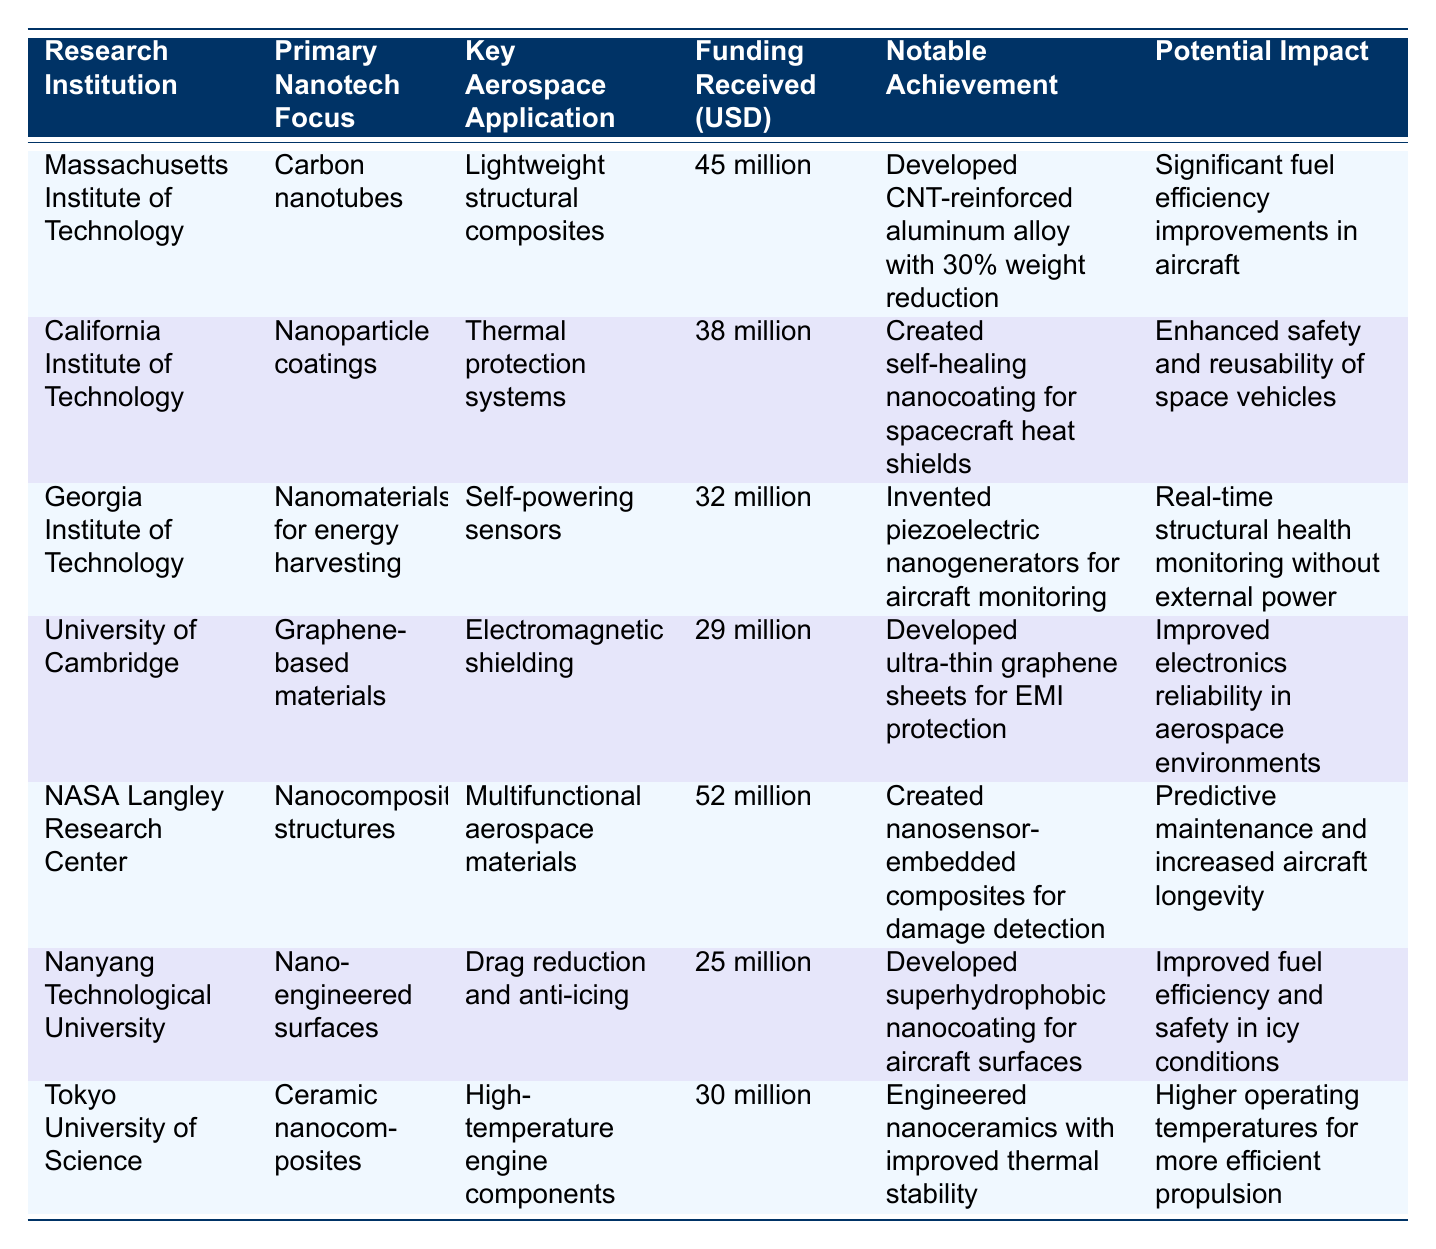What is the primary nanotechnology focus of the Georgia Institute of Technology? The table indicates that the primary nanotechnology focus of the Georgia Institute of Technology is "Nanomaterials for energy harvesting."
Answer: Nanomaterials for energy harvesting What is the notable achievement of the Massachusetts Institute of Technology? According to the table, the notable achievement of the Massachusetts Institute of Technology is "Developed CNT-reinforced aluminum alloy with 30% weight reduction."
Answer: Developed CNT-reinforced aluminum alloy with 30% weight reduction What is the total funding received by NASA Langley Research Center and California Institute of Technology combined? The funding for NASA Langley Research Center is 52 million, and for California Institute of Technology, it is 38 million. Adding these together, 52 + 38 equals 90 million.
Answer: 90 million Is Nanyang Technological University focused on lightweight structural composites? The table states that the primary nanotech focus of Nanyang Technological University is "Nano-engineered surfaces" not lightweight structural composites, which are the focus of MIT.
Answer: No Which institution has the highest funding received, and what is the amount? By inspecting the funding column, it is clear that NASA Langley Research Center has received the highest funding of 52 million.
Answer: NASA Langley Research Center, 52 million Calculate the average funding received by all institutions listed in the table. Summing the funding amounts: 45 + 38 + 32 + 29 + 52 + 25 + 30 gives us a total of 251 million. There are 7 institutions, so the average is 251/7, which is approximately 35.857 million.
Answer: Approximately 35.857 million What is the key aerospace application of the University of Cambridge? The key aerospace application for the University of Cambridge is "Electromagnetic shielding," as indicated in the table.
Answer: Electromagnetic shielding Is the notable achievement for Georgia Institute of Technology related to thermal protection systems? The table shows that the notable achievement for Georgia Institute of Technology is "Invented piezoelectric nanogenerators for aircraft monitoring," which is related to self-powering sensors, not thermal protection systems.
Answer: No Which research institution developed advanced coatings for spacecraft, and what is the key aerospace application? From the table, it can be identified that the California Institute of Technology developed self-healing nanocoating for spacecraft heat shields, with the key application being "Thermal protection systems."
Answer: California Institute of Technology, Thermal protection systems 